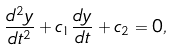<formula> <loc_0><loc_0><loc_500><loc_500>\frac { d ^ { 2 } y } { d t ^ { 2 } } + c _ { 1 } \frac { d y } { d t } + c _ { 2 } = 0 ,</formula> 